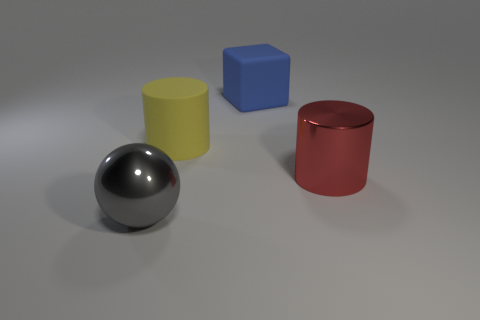What number of objects are large cylinders behind the big red metallic cylinder or big cylinders?
Make the answer very short. 2. The rubber thing behind the cylinder on the left side of the big rubber thing that is to the right of the large yellow object is what color?
Your response must be concise. Blue. What color is the big block that is the same material as the big yellow thing?
Offer a terse response. Blue. How many big red cylinders are the same material as the gray thing?
Offer a terse response. 1. There is a metal object to the right of the ball; does it have the same size as the big rubber cylinder?
Give a very brief answer. Yes. What is the color of the ball that is the same size as the yellow matte cylinder?
Give a very brief answer. Gray. What number of cylinders are behind the red thing?
Keep it short and to the point. 1. Are there any big gray things?
Offer a terse response. Yes. What is the size of the shiny object on the right side of the cylinder that is to the left of the shiny object that is behind the gray shiny thing?
Keep it short and to the point. Large. What number of other objects are the same size as the yellow cylinder?
Ensure brevity in your answer.  3. 